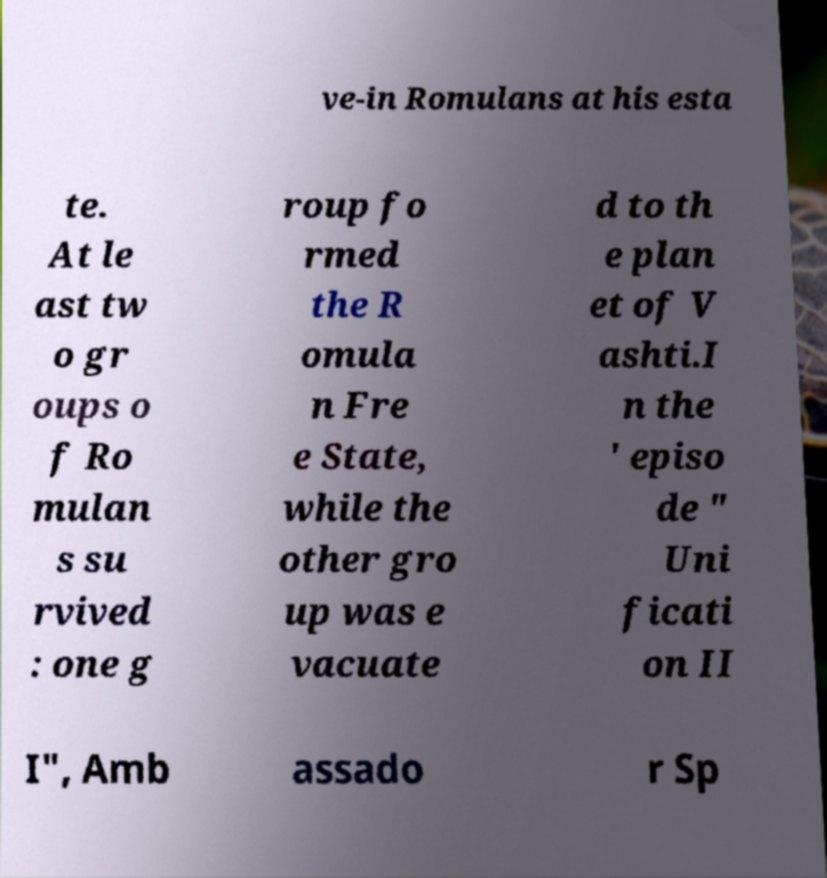I need the written content from this picture converted into text. Can you do that? ve-in Romulans at his esta te. At le ast tw o gr oups o f Ro mulan s su rvived : one g roup fo rmed the R omula n Fre e State, while the other gro up was e vacuate d to th e plan et of V ashti.I n the ' episo de " Uni ficati on II I", Amb assado r Sp 